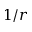<formula> <loc_0><loc_0><loc_500><loc_500>1 / r</formula> 